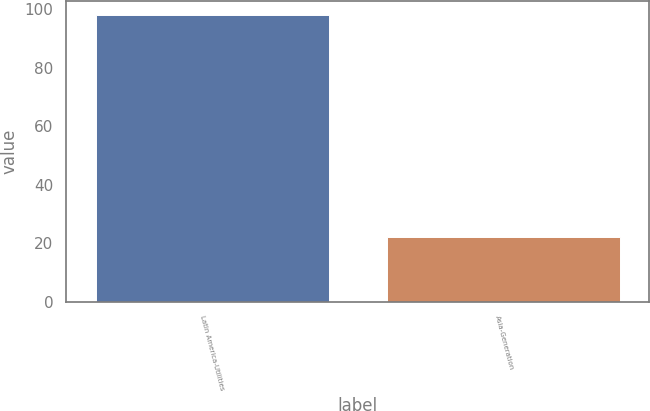<chart> <loc_0><loc_0><loc_500><loc_500><bar_chart><fcel>Latin America-Utilities<fcel>Asia-Generation<nl><fcel>98<fcel>22<nl></chart> 